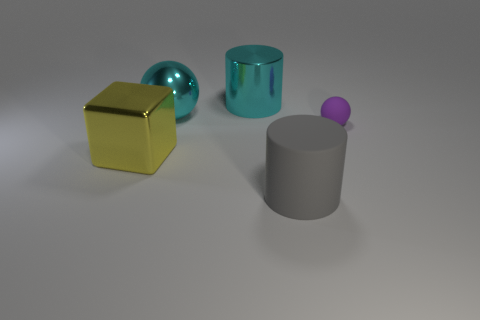What number of balls are made of the same material as the big yellow thing?
Make the answer very short. 1. There is a gray rubber object that is right of the big yellow cube; what number of large things are behind it?
Provide a succinct answer. 3. There is a metal object that is in front of the rubber sphere; is its color the same as the sphere that is to the left of the tiny purple thing?
Keep it short and to the point. No. There is a thing that is both in front of the tiny sphere and behind the large gray cylinder; what is its shape?
Your response must be concise. Cube. Are there any large metal things that have the same shape as the gray matte thing?
Your answer should be compact. Yes. The yellow object that is the same size as the cyan metallic cylinder is what shape?
Offer a very short reply. Cube. What is the material of the large ball?
Your response must be concise. Metal. What is the size of the thing right of the large rubber cylinder that is on the right side of the large shiny cylinder that is left of the gray rubber cylinder?
Provide a short and direct response. Small. What is the material of the large cylinder that is the same color as the large sphere?
Your answer should be compact. Metal. What number of metallic objects are cylinders or big yellow blocks?
Ensure brevity in your answer.  2. 